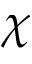<formula> <loc_0><loc_0><loc_500><loc_500>\chi</formula> 